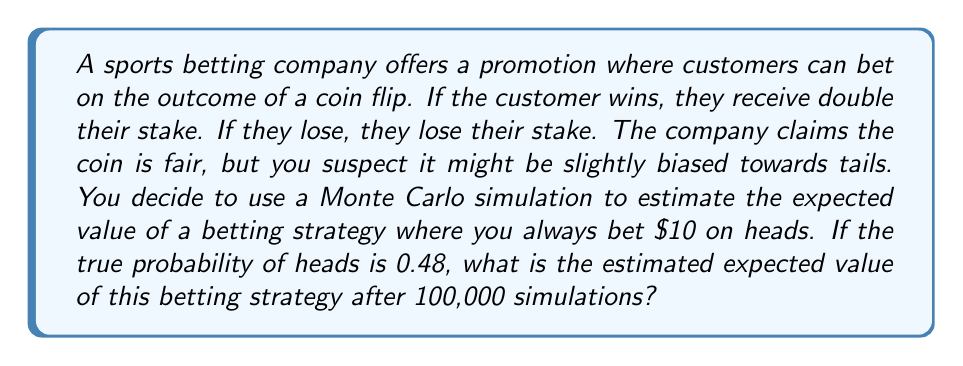Show me your answer to this math problem. To solve this problem using Monte Carlo simulations, we'll follow these steps:

1) First, let's define our betting strategy:
   - Bet amount: $10
   - Bet on: Heads
   - Win: Receive $20 (double the stake)
   - Lose: Lose $10 (the stake)

2) The true probability of heads is given as 0.48

3) For each simulation:
   - Generate a random number between 0 and 1
   - If the number is less than or equal to 0.48, it's a win (heads)
   - If the number is greater than 0.48, it's a loss (tails)

4) Calculate the outcome for each simulation:
   - If win: $20 - $10 = $10 profit
   - If lose: -$10 loss

5) Repeat this process 100,000 times

6) Calculate the average outcome, which is our estimated expected value

Let's implement this in Python:

```python
import numpy as np

np.random.seed(0)  # for reproducibility

n_simulations = 100000
p_heads = 0.48
bet_amount = 10

outcomes = np.where(np.random.random(n_simulations) <= p_heads, 10, -10)
expected_value = np.mean(outcomes)
```

The expected value can be calculated theoretically as well:

$$ E = p(win) \cdot \text{win amount} + p(lose) \cdot \text{lose amount} $$
$$ E = 0.48 \cdot 10 + 0.52 \cdot (-10) = 4.8 - 5.2 = -0.4 $$

This means we expect to lose 40 cents per bet on average.

The Monte Carlo simulation should give us a result close to this theoretical value, with some small variation due to randomness.
Answer: The estimated expected value after 100,000 Monte Carlo simulations is approximately $-0.40 per bet. 